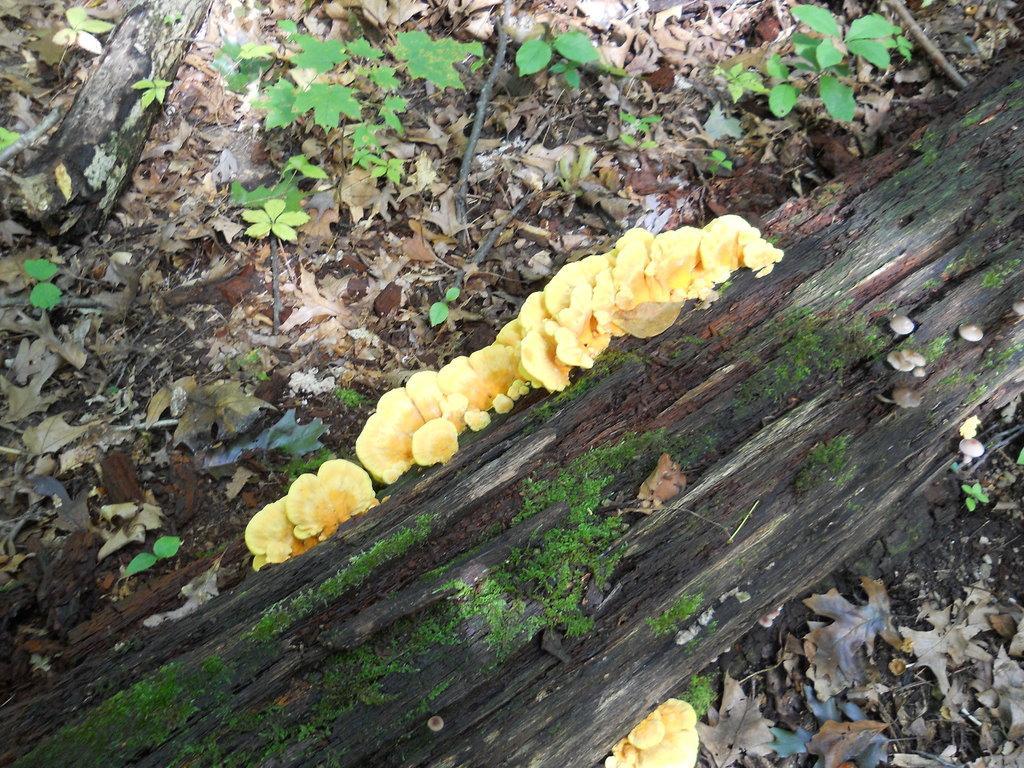Could you give a brief overview of what you see in this image? In this picture we can see some plants here, there is wood here, we can see some leaves at the bottom. 